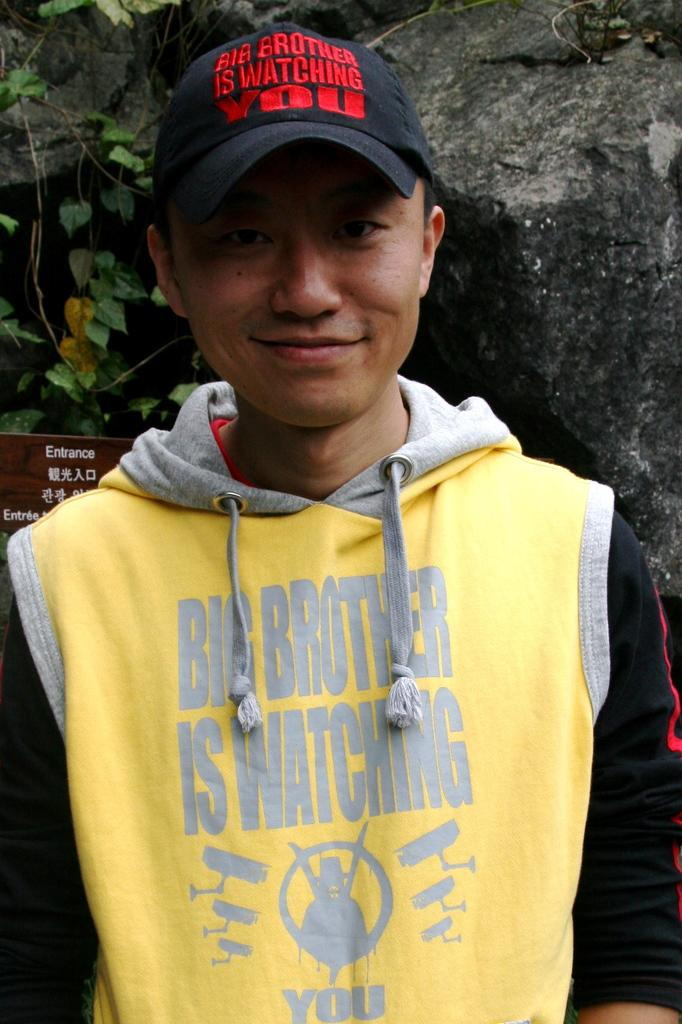What is the person in the image wearing on their head? The person in the image is wearing a cap. What is written on the wooden board in the image? There is a wooden board with text in the image. What type of natural elements can be seen in the background of the image? Rocks and a plant are visible in the background of the image. What time does the clock in the image show? There is no clock present in the image. What request is the person in the image making? The image does not show any request being made by the person. 